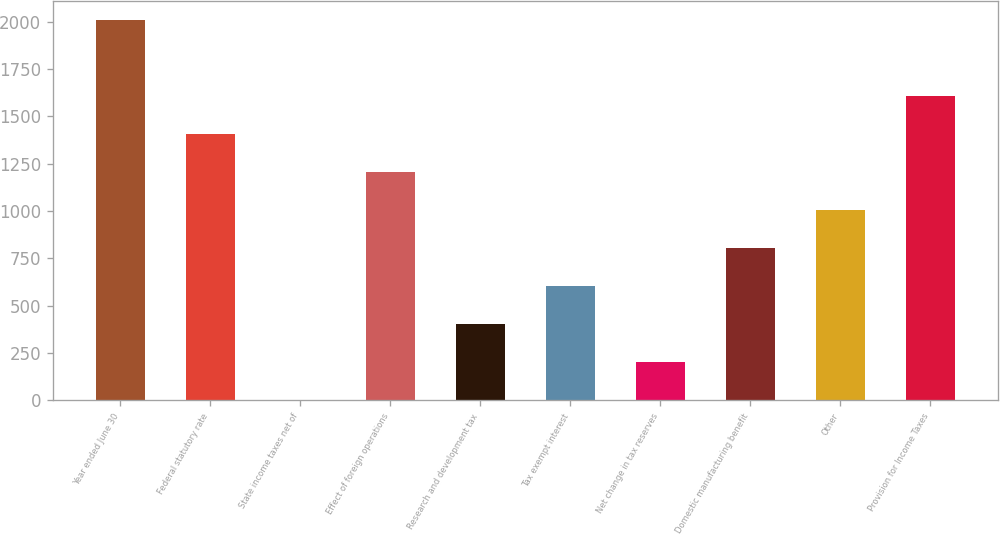Convert chart to OTSL. <chart><loc_0><loc_0><loc_500><loc_500><bar_chart><fcel>Year ended June 30<fcel>Federal statutory rate<fcel>State income taxes net of<fcel>Effect of foreign operations<fcel>Research and development tax<fcel>Tax exempt interest<fcel>Net change in tax reserves<fcel>Domestic manufacturing benefit<fcel>Other<fcel>Provision for Income Taxes<nl><fcel>2008<fcel>1405.72<fcel>0.4<fcel>1204.96<fcel>401.92<fcel>602.68<fcel>201.16<fcel>803.44<fcel>1004.2<fcel>1606.48<nl></chart> 